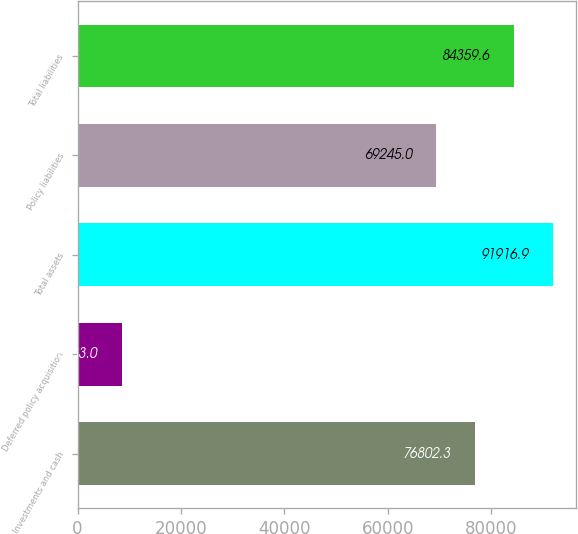<chart> <loc_0><loc_0><loc_500><loc_500><bar_chart><fcel>Investments and cash<fcel>Deferred policy acquisition<fcel>Total assets<fcel>Policy liabilities<fcel>Total liabilities<nl><fcel>76802.3<fcel>8533<fcel>91916.9<fcel>69245<fcel>84359.6<nl></chart> 